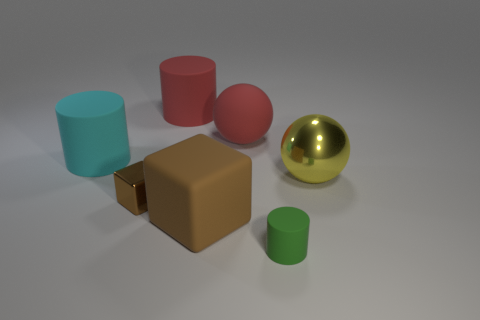There is a large matte object that is to the left of the big brown rubber cube and in front of the big red cylinder; what is its shape?
Provide a short and direct response. Cylinder. Does the metallic thing right of the green rubber cylinder have the same size as the sphere left of the yellow thing?
Ensure brevity in your answer.  Yes. There is a large brown thing that is the same material as the small green object; what shape is it?
Your answer should be very brief. Cube. There is a metal object that is to the left of the ball that is in front of the ball behind the shiny ball; what is its color?
Your response must be concise. Brown. Are there fewer cyan cylinders that are in front of the green rubber cylinder than matte things to the right of the large cyan cylinder?
Make the answer very short. Yes. Is the shape of the tiny brown metal object the same as the large brown rubber object?
Give a very brief answer. Yes. What number of red cylinders have the same size as the green object?
Make the answer very short. 0. Is the number of large brown blocks behind the big yellow sphere less than the number of small gray things?
Offer a terse response. No. What is the size of the metal thing that is to the left of the yellow ball that is behind the rubber block?
Offer a very short reply. Small. What number of things are big green rubber things or brown things?
Your response must be concise. 2. 